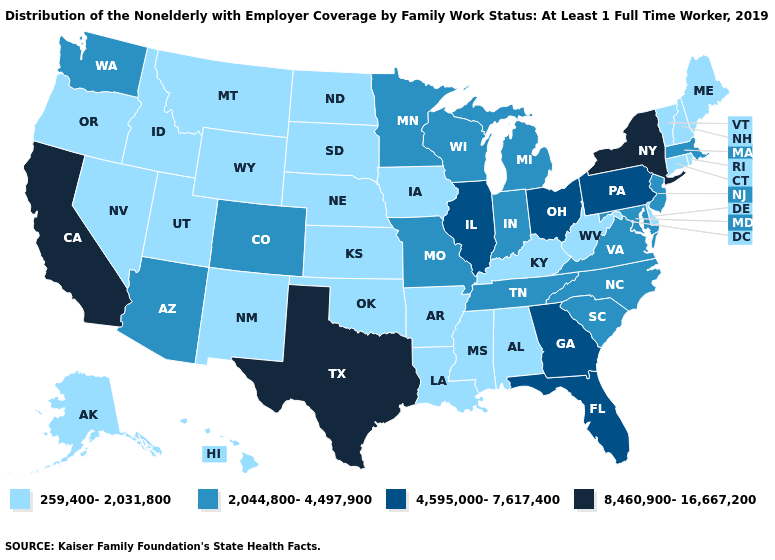What is the value of Tennessee?
Write a very short answer. 2,044,800-4,497,900. Which states have the lowest value in the South?
Write a very short answer. Alabama, Arkansas, Delaware, Kentucky, Louisiana, Mississippi, Oklahoma, West Virginia. What is the value of Tennessee?
Concise answer only. 2,044,800-4,497,900. Does West Virginia have a lower value than Wisconsin?
Answer briefly. Yes. Name the states that have a value in the range 259,400-2,031,800?
Answer briefly. Alabama, Alaska, Arkansas, Connecticut, Delaware, Hawaii, Idaho, Iowa, Kansas, Kentucky, Louisiana, Maine, Mississippi, Montana, Nebraska, Nevada, New Hampshire, New Mexico, North Dakota, Oklahoma, Oregon, Rhode Island, South Dakota, Utah, Vermont, West Virginia, Wyoming. Name the states that have a value in the range 8,460,900-16,667,200?
Be succinct. California, New York, Texas. Name the states that have a value in the range 4,595,000-7,617,400?
Answer briefly. Florida, Georgia, Illinois, Ohio, Pennsylvania. What is the highest value in the USA?
Answer briefly. 8,460,900-16,667,200. Does the first symbol in the legend represent the smallest category?
Concise answer only. Yes. Which states have the lowest value in the USA?
Concise answer only. Alabama, Alaska, Arkansas, Connecticut, Delaware, Hawaii, Idaho, Iowa, Kansas, Kentucky, Louisiana, Maine, Mississippi, Montana, Nebraska, Nevada, New Hampshire, New Mexico, North Dakota, Oklahoma, Oregon, Rhode Island, South Dakota, Utah, Vermont, West Virginia, Wyoming. What is the value of Oregon?
Write a very short answer. 259,400-2,031,800. Among the states that border Minnesota , does South Dakota have the highest value?
Keep it brief. No. Among the states that border Louisiana , which have the highest value?
Keep it brief. Texas. What is the highest value in states that border Maine?
Keep it brief. 259,400-2,031,800. Does the map have missing data?
Short answer required. No. 